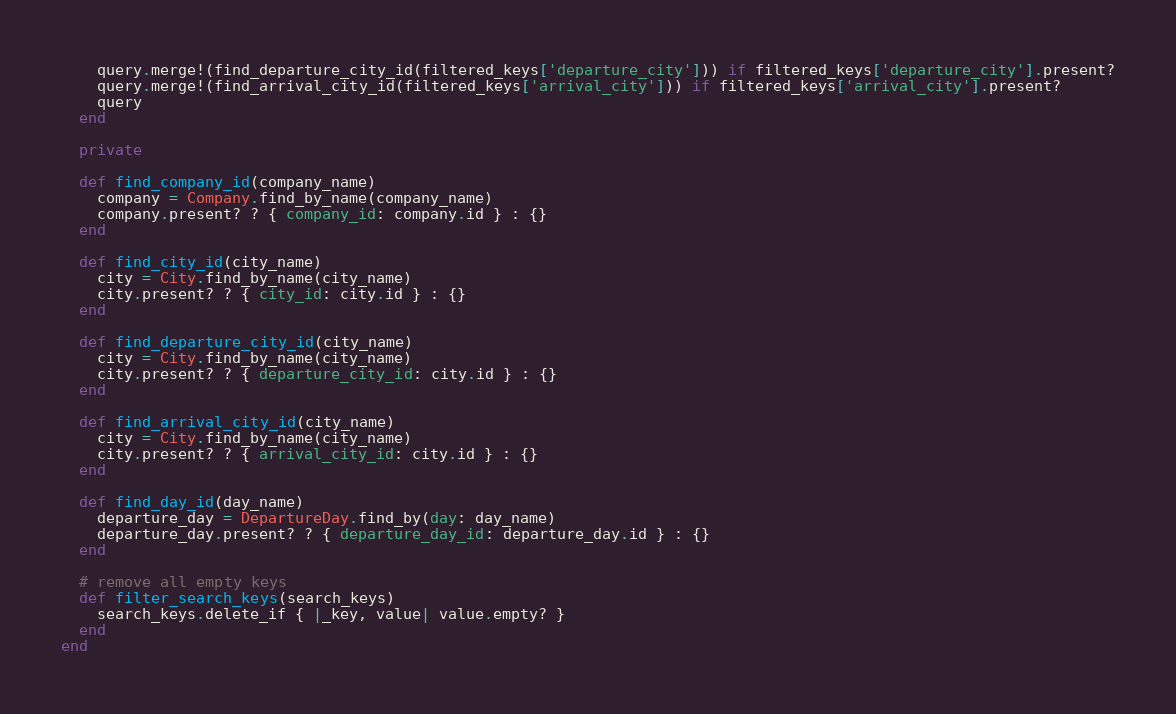Convert code to text. <code><loc_0><loc_0><loc_500><loc_500><_Ruby_>    query.merge!(find_departure_city_id(filtered_keys['departure_city'])) if filtered_keys['departure_city'].present?
    query.merge!(find_arrival_city_id(filtered_keys['arrival_city'])) if filtered_keys['arrival_city'].present?
    query
  end

  private

  def find_company_id(company_name)
    company = Company.find_by_name(company_name)
    company.present? ? { company_id: company.id } : {}
  end

  def find_city_id(city_name)
    city = City.find_by_name(city_name)
    city.present? ? { city_id: city.id } : {}
  end

  def find_departure_city_id(city_name)
    city = City.find_by_name(city_name)
    city.present? ? { departure_city_id: city.id } : {}
  end

  def find_arrival_city_id(city_name)
    city = City.find_by_name(city_name)
    city.present? ? { arrival_city_id: city.id } : {}
  end

  def find_day_id(day_name)
    departure_day = DepartureDay.find_by(day: day_name)
    departure_day.present? ? { departure_day_id: departure_day.id } : {}
  end

  # remove all empty keys
  def filter_search_keys(search_keys)
    search_keys.delete_if { |_key, value| value.empty? }
  end
end
</code> 